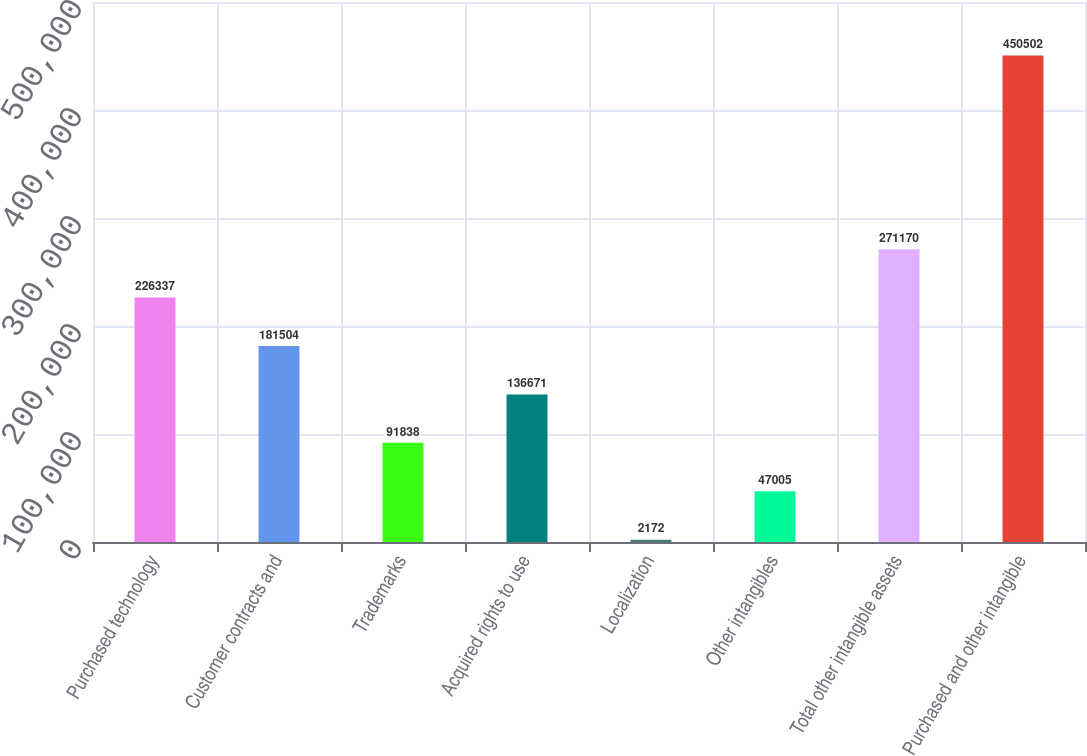<chart> <loc_0><loc_0><loc_500><loc_500><bar_chart><fcel>Purchased technology<fcel>Customer contracts and<fcel>Trademarks<fcel>Acquired rights to use<fcel>Localization<fcel>Other intangibles<fcel>Total other intangible assets<fcel>Purchased and other intangible<nl><fcel>226337<fcel>181504<fcel>91838<fcel>136671<fcel>2172<fcel>47005<fcel>271170<fcel>450502<nl></chart> 